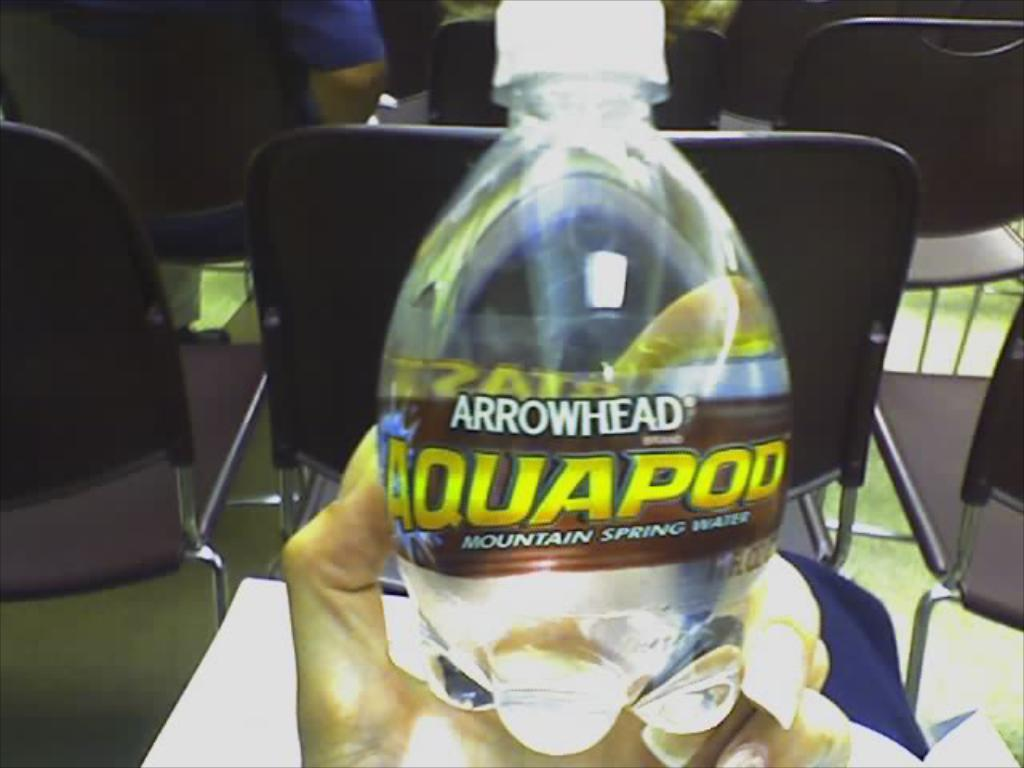What object is being held by someone in the image? There is a water bottle in the image, and it is being held by someone. What else can be seen in the image besides the water bottle? There are chairs in the image. Can you see any bubbles coming from the water bottle in the image? There are no bubbles visible in the image; it only shows a water bottle being held by someone and chairs in the background. 